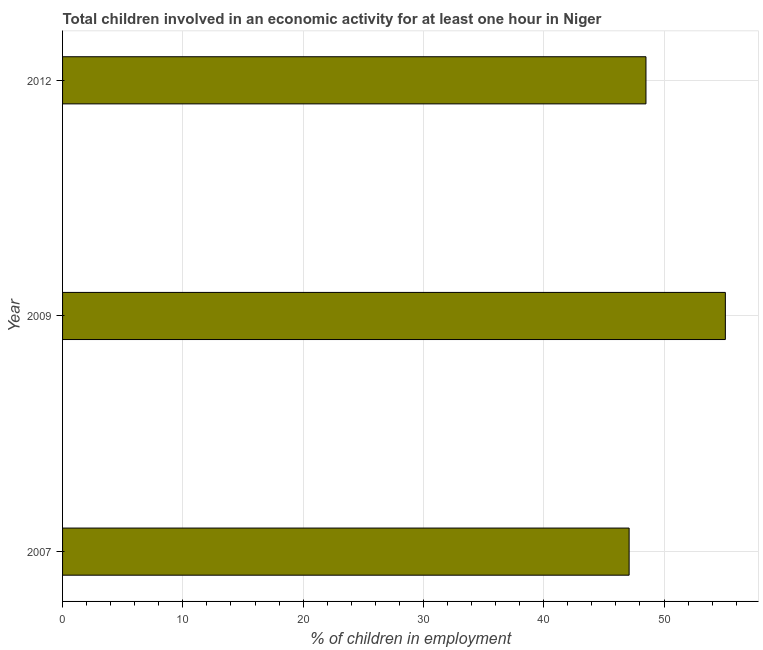What is the title of the graph?
Your answer should be compact. Total children involved in an economic activity for at least one hour in Niger. What is the label or title of the X-axis?
Offer a terse response. % of children in employment. What is the percentage of children in employment in 2009?
Offer a very short reply. 55.1. Across all years, what is the maximum percentage of children in employment?
Keep it short and to the point. 55.1. Across all years, what is the minimum percentage of children in employment?
Provide a succinct answer. 47.1. What is the sum of the percentage of children in employment?
Offer a very short reply. 150.7. What is the difference between the percentage of children in employment in 2009 and 2012?
Your response must be concise. 6.6. What is the average percentage of children in employment per year?
Your answer should be very brief. 50.23. What is the median percentage of children in employment?
Provide a succinct answer. 48.5. What is the ratio of the percentage of children in employment in 2007 to that in 2009?
Keep it short and to the point. 0.85. Is the percentage of children in employment in 2007 less than that in 2009?
Give a very brief answer. Yes. Is the difference between the percentage of children in employment in 2007 and 2009 greater than the difference between any two years?
Your answer should be very brief. Yes. What is the difference between the highest and the second highest percentage of children in employment?
Give a very brief answer. 6.6. In how many years, is the percentage of children in employment greater than the average percentage of children in employment taken over all years?
Make the answer very short. 1. Are the values on the major ticks of X-axis written in scientific E-notation?
Provide a succinct answer. No. What is the % of children in employment in 2007?
Give a very brief answer. 47.1. What is the % of children in employment in 2009?
Keep it short and to the point. 55.1. What is the % of children in employment in 2012?
Provide a short and direct response. 48.5. What is the difference between the % of children in employment in 2007 and 2009?
Make the answer very short. -8. What is the difference between the % of children in employment in 2009 and 2012?
Make the answer very short. 6.6. What is the ratio of the % of children in employment in 2007 to that in 2009?
Give a very brief answer. 0.85. What is the ratio of the % of children in employment in 2007 to that in 2012?
Keep it short and to the point. 0.97. What is the ratio of the % of children in employment in 2009 to that in 2012?
Provide a short and direct response. 1.14. 